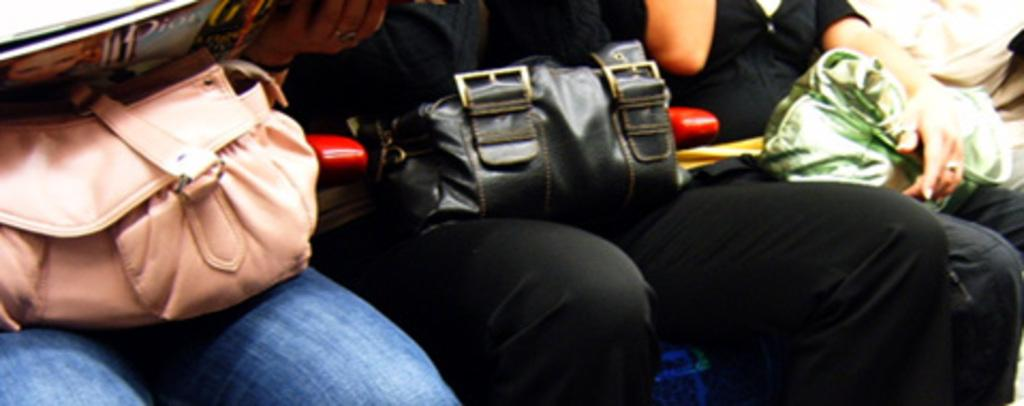How many people are sitting on the chair in the image? There are three persons sitting on a chair in the image. What colors of bags can be seen in the image? There is a peach-colored bag, a black bag, and a green bag in the image. Can you tell me how many times the clock runs in the image? There is no clock present in the image, so it is not possible to determine how many times it runs. 